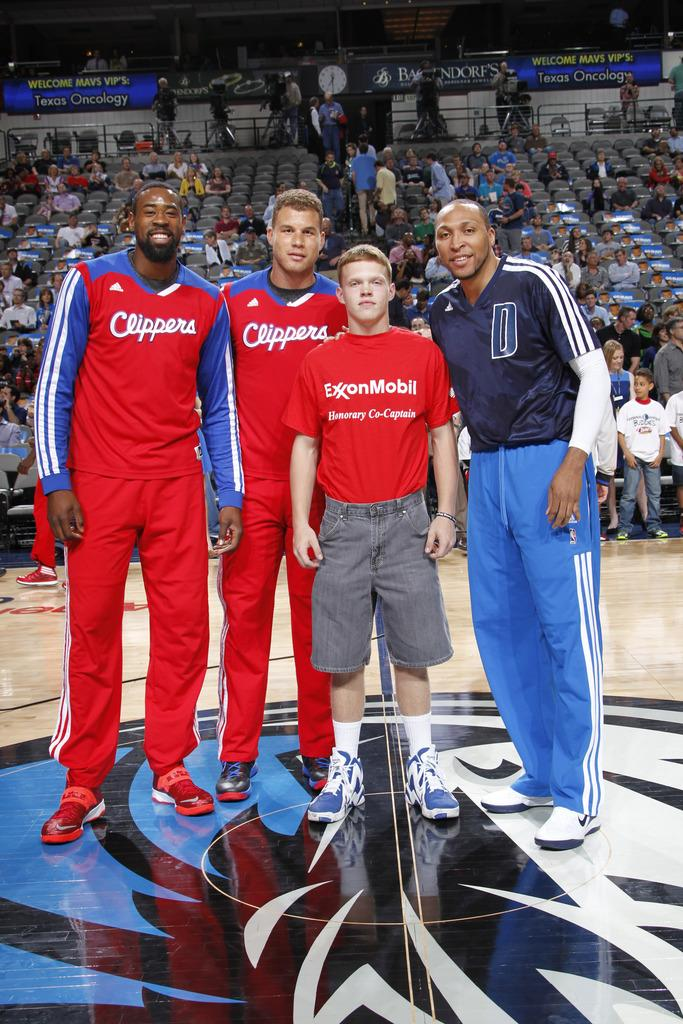Provide a one-sentence caption for the provided image. Players taking a photo with a boy wearing a shirt which says ExxonMobil. 